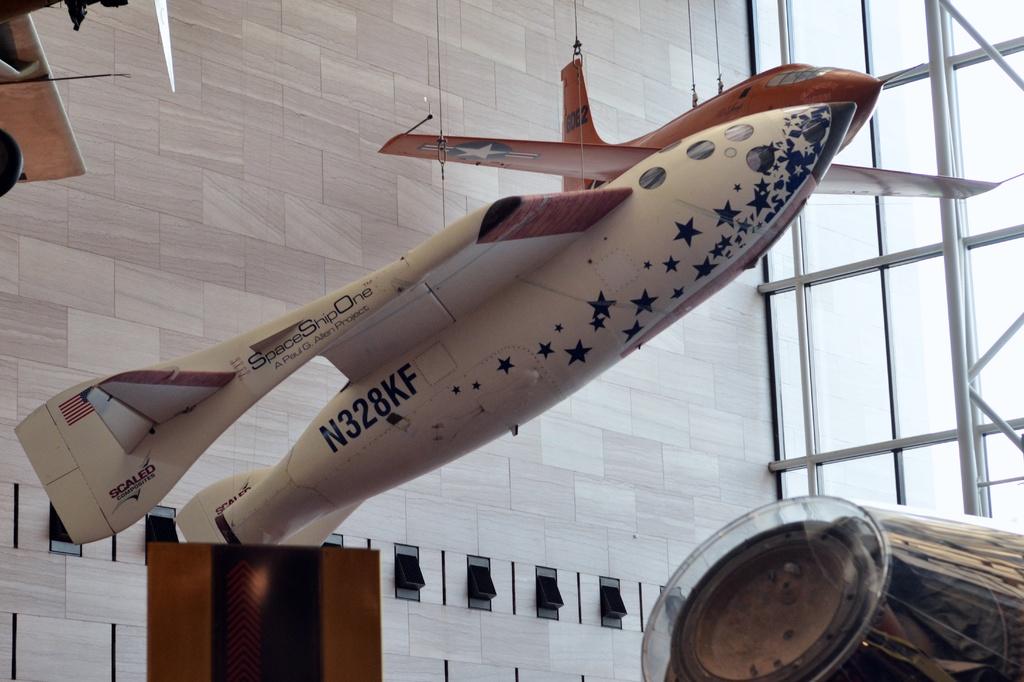What is the plane's tail number?
Provide a succinct answer. N328kf. What is the name of this space ship?
Offer a terse response. Spaceshipone. 